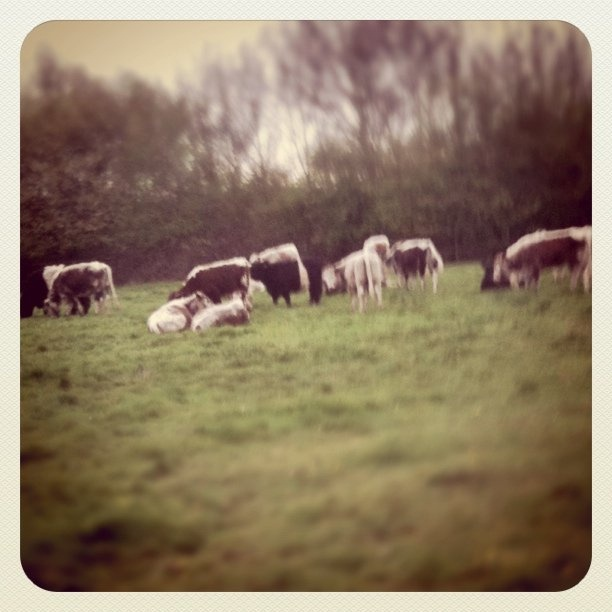Describe the objects in this image and their specific colors. I can see cow in ivory, maroon, gray, brown, and black tones, cow in ivory, maroon, black, brown, and gray tones, cow in ivory, purple, black, brown, and gray tones, cow in ivory, maroon, brown, and gray tones, and cow in ivory, tan, gray, and lightgray tones in this image. 